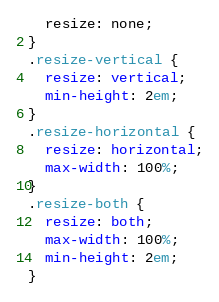Convert code to text. <code><loc_0><loc_0><loc_500><loc_500><_CSS_>  resize: none;
}
.resize-vertical {
  resize: vertical;
  min-height: 2em;
}
.resize-horizontal {
  resize: horizontal;
  max-width: 100%;
}
.resize-both {
  resize: both;
  max-width: 100%;
  min-height: 2em;
}
</code> 